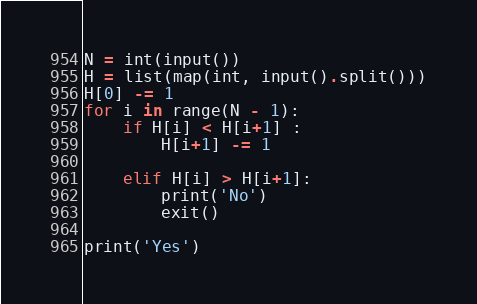<code> <loc_0><loc_0><loc_500><loc_500><_Python_>N = int(input())
H = list(map(int, input().split()))
H[0] -= 1
for i in range(N - 1):
    if H[i] < H[i+1] :
        H[i+1] -= 1

    elif H[i] > H[i+1]:
        print('No')
        exit()

print('Yes')
</code> 